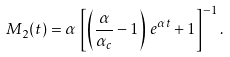<formula> <loc_0><loc_0><loc_500><loc_500>M _ { 2 } ( t ) = \alpha \, \left [ \left ( \frac { \alpha } { \alpha _ { c } } - 1 \right ) \, e ^ { \alpha t } + 1 \right ] ^ { - 1 } .</formula> 